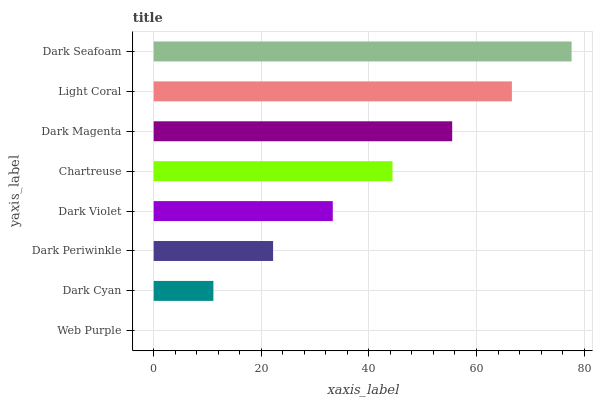Is Web Purple the minimum?
Answer yes or no. Yes. Is Dark Seafoam the maximum?
Answer yes or no. Yes. Is Dark Cyan the minimum?
Answer yes or no. No. Is Dark Cyan the maximum?
Answer yes or no. No. Is Dark Cyan greater than Web Purple?
Answer yes or no. Yes. Is Web Purple less than Dark Cyan?
Answer yes or no. Yes. Is Web Purple greater than Dark Cyan?
Answer yes or no. No. Is Dark Cyan less than Web Purple?
Answer yes or no. No. Is Chartreuse the high median?
Answer yes or no. Yes. Is Dark Violet the low median?
Answer yes or no. Yes. Is Dark Seafoam the high median?
Answer yes or no. No. Is Dark Magenta the low median?
Answer yes or no. No. 